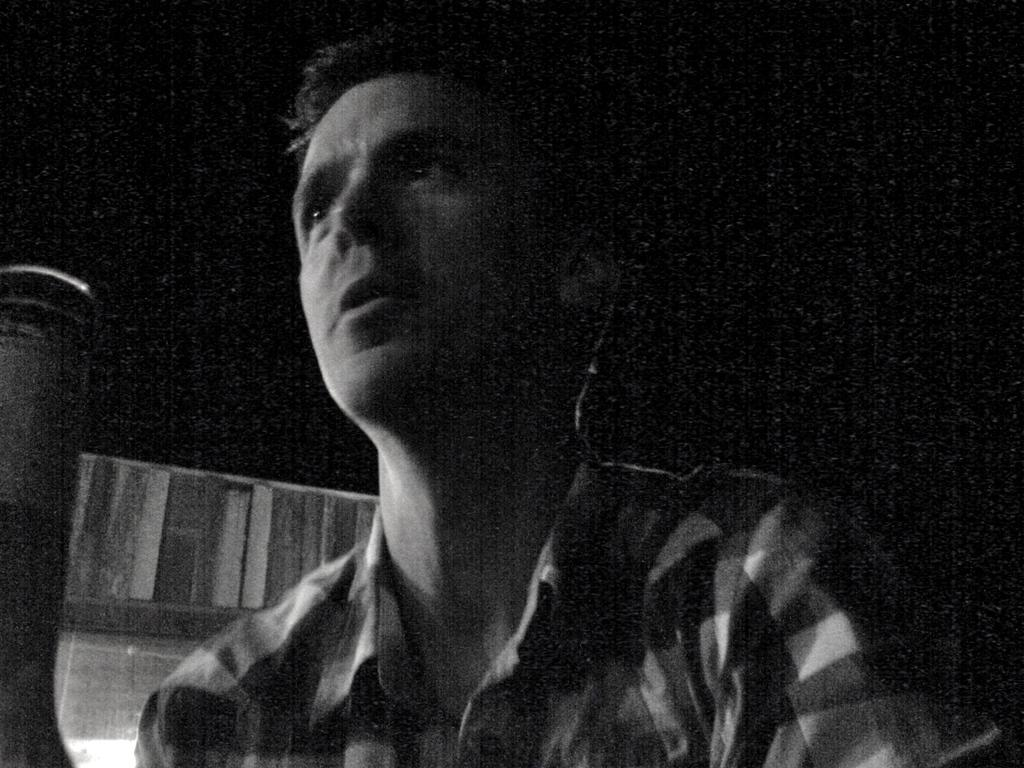Who is present in the image? There is a man in the image. What is the man holding in the image? The man is holding a glass. What can be seen in the background of the image? There is a door visible in the background of the image. What is the color of the background in the image? The background of the image is black. What type of cake is the man cutting in the image? There is no cake present in the image; the man is holding a glass. What emotion is the man displaying in the image? The provided facts do not mention the man's emotions or expressions, so it cannot be determined from the image. 